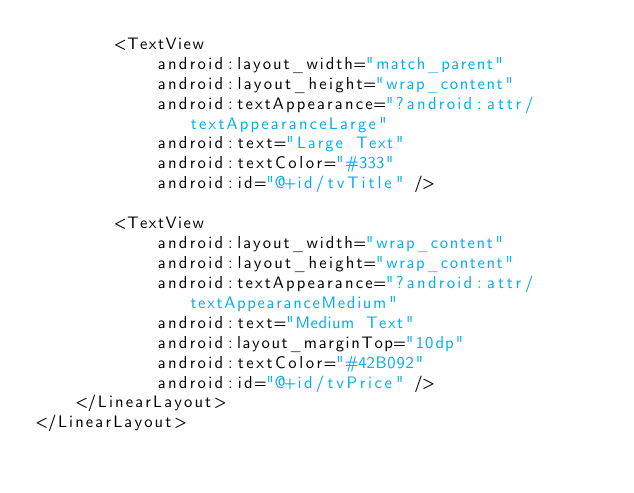<code> <loc_0><loc_0><loc_500><loc_500><_XML_>        <TextView
            android:layout_width="match_parent"
            android:layout_height="wrap_content"
            android:textAppearance="?android:attr/textAppearanceLarge"
            android:text="Large Text"
            android:textColor="#333"
            android:id="@+id/tvTitle" />

        <TextView
            android:layout_width="wrap_content"
            android:layout_height="wrap_content"
            android:textAppearance="?android:attr/textAppearanceMedium"
            android:text="Medium Text"
            android:layout_marginTop="10dp"
            android:textColor="#42B092"
            android:id="@+id/tvPrice" />
    </LinearLayout>
</LinearLayout>
</code> 